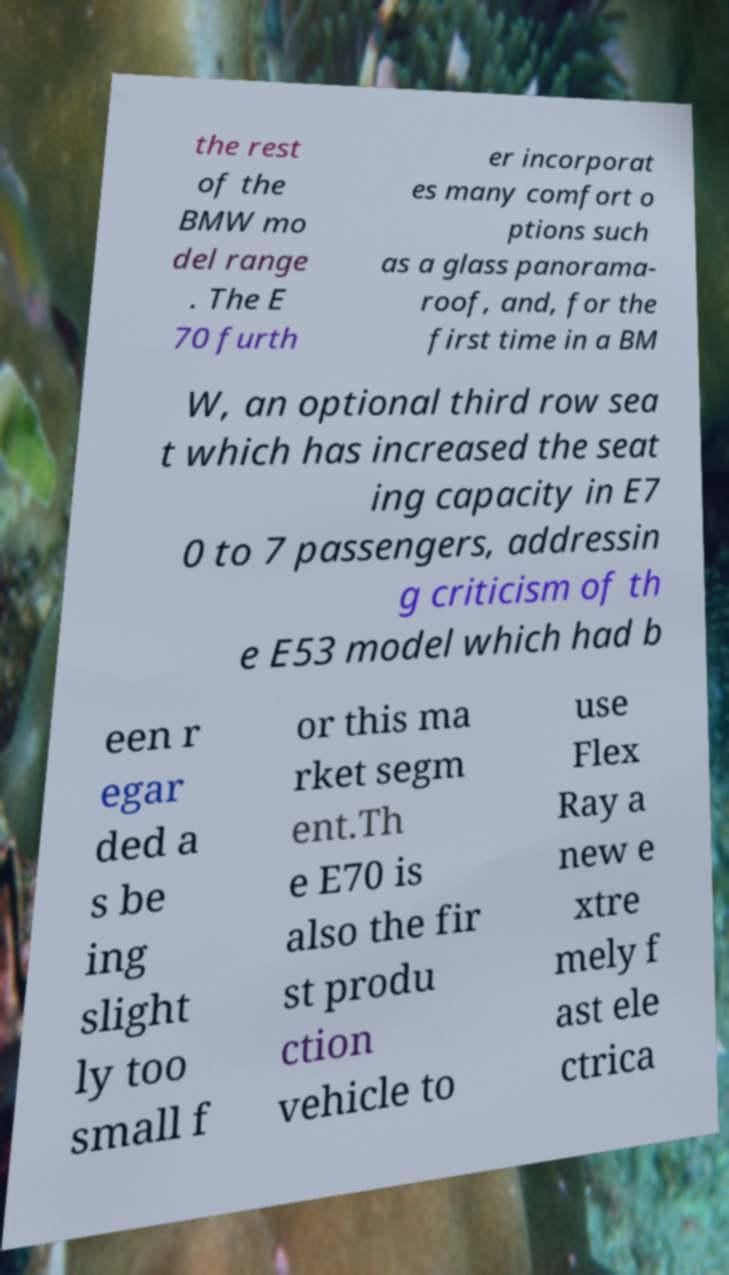Please identify and transcribe the text found in this image. the rest of the BMW mo del range . The E 70 furth er incorporat es many comfort o ptions such as a glass panorama- roof, and, for the first time in a BM W, an optional third row sea t which has increased the seat ing capacity in E7 0 to 7 passengers, addressin g criticism of th e E53 model which had b een r egar ded a s be ing slight ly too small f or this ma rket segm ent.Th e E70 is also the fir st produ ction vehicle to use Flex Ray a new e xtre mely f ast ele ctrica 